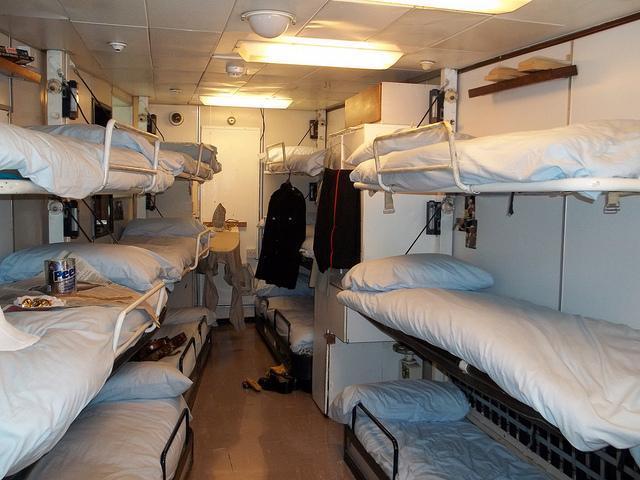How many beds can be seen?
Give a very brief answer. 8. 